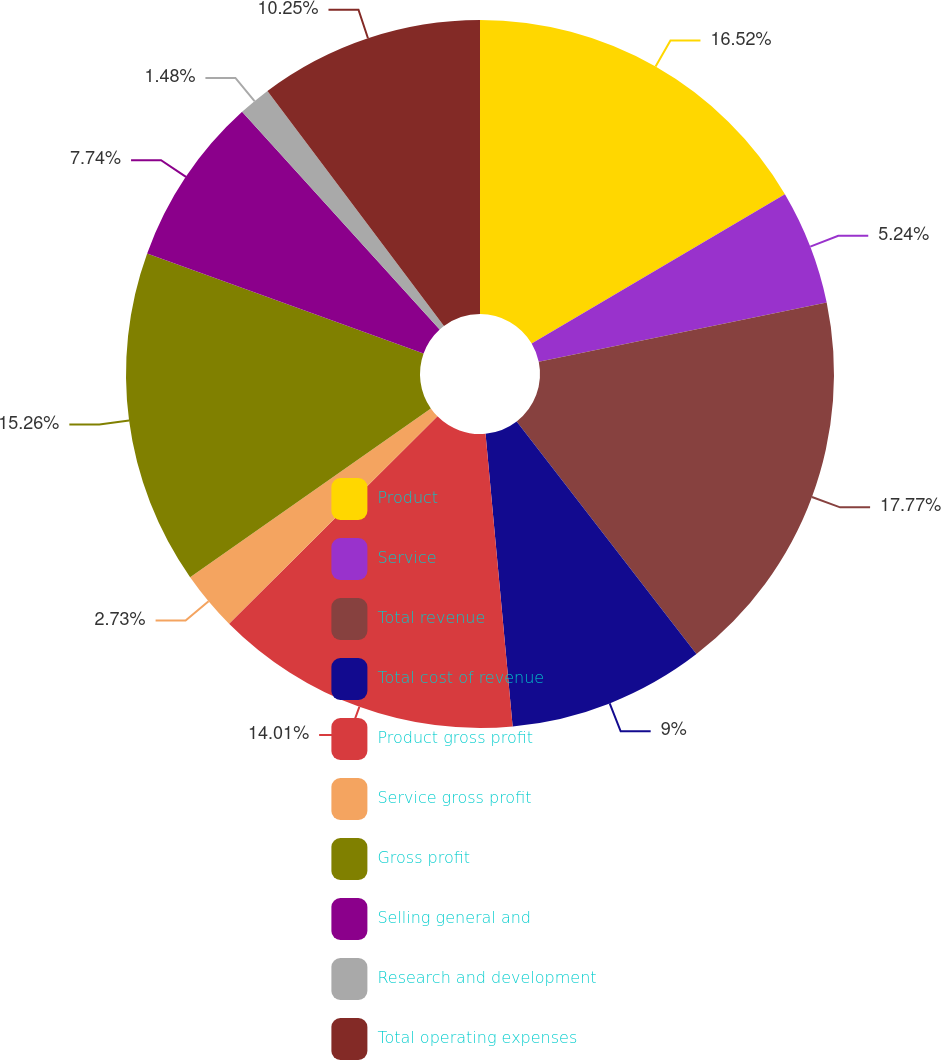Convert chart. <chart><loc_0><loc_0><loc_500><loc_500><pie_chart><fcel>Product<fcel>Service<fcel>Total revenue<fcel>Total cost of revenue<fcel>Product gross profit<fcel>Service gross profit<fcel>Gross profit<fcel>Selling general and<fcel>Research and development<fcel>Total operating expenses<nl><fcel>16.52%<fcel>5.24%<fcel>17.77%<fcel>9.0%<fcel>14.01%<fcel>2.73%<fcel>15.26%<fcel>7.74%<fcel>1.48%<fcel>10.25%<nl></chart> 